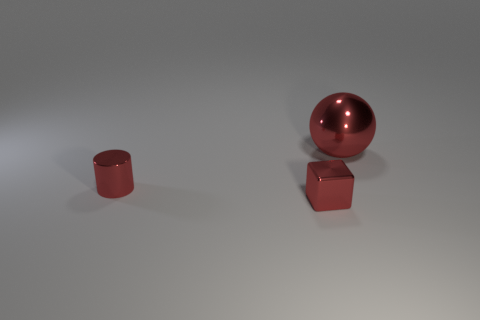The cylinder that is made of the same material as the small red block is what color? red 